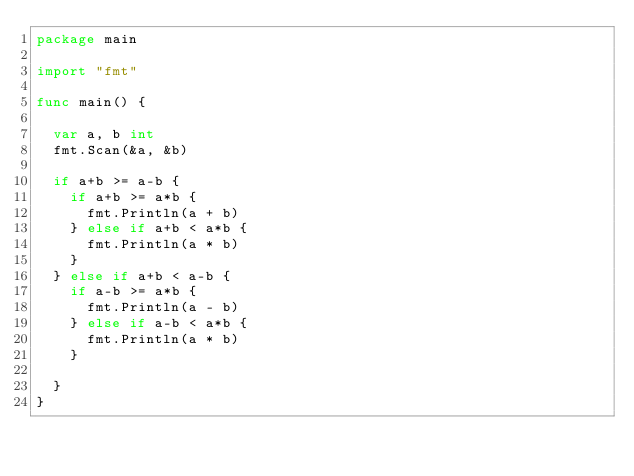<code> <loc_0><loc_0><loc_500><loc_500><_Go_>package main

import "fmt"

func main() {

	var a, b int
	fmt.Scan(&a, &b)

	if a+b >= a-b {
		if a+b >= a*b {
			fmt.Println(a + b)
		} else if a+b < a*b {
			fmt.Println(a * b)
		}
	} else if a+b < a-b {
		if a-b >= a*b {
			fmt.Println(a - b)
		} else if a-b < a*b {
			fmt.Println(a * b)
		}

	}
}
</code> 